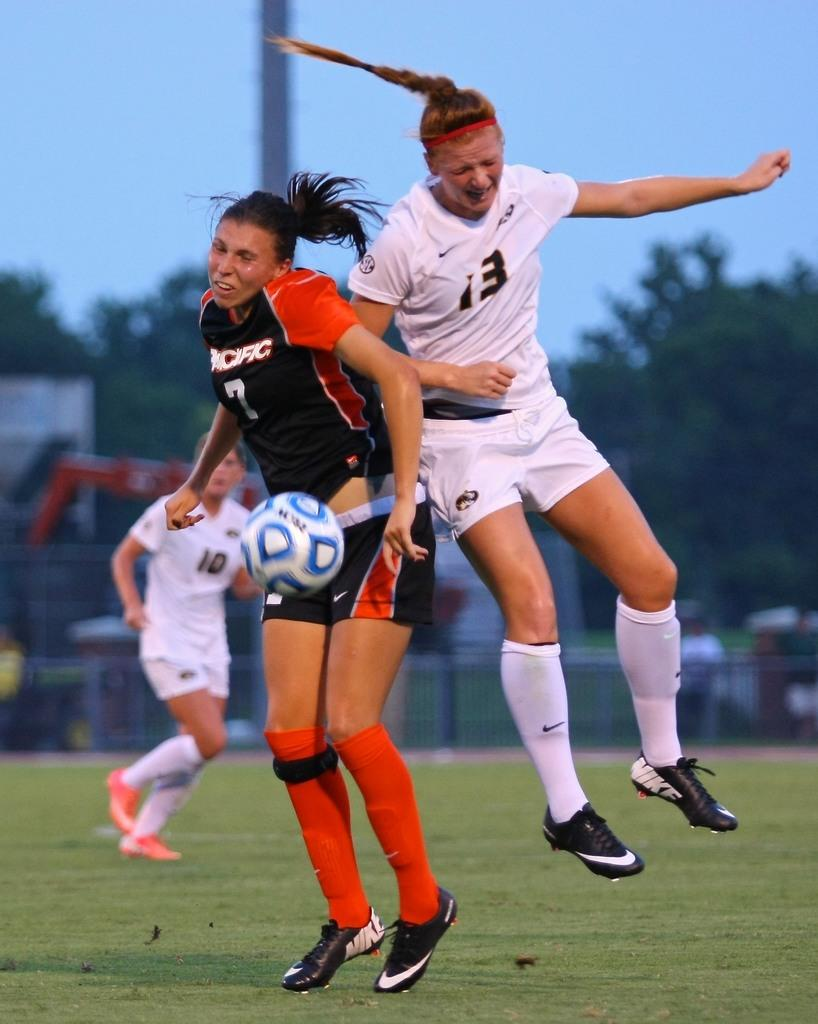<image>
Write a terse but informative summary of the picture. Soccer player wearing number 13 trying to get the soccer ball. 